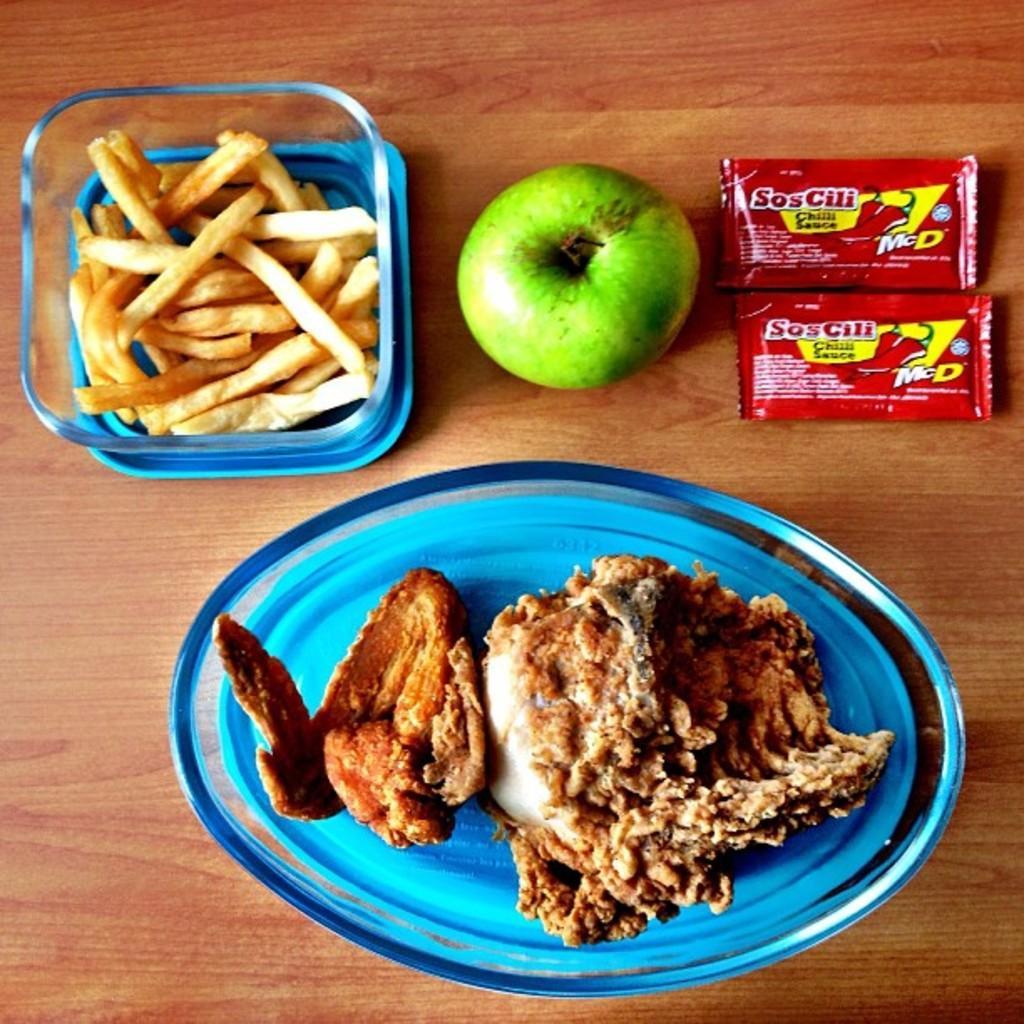Please provide a concise description of this image. In this image we can see a green apple, sauce packets, a bowl of french fries and also a plate of food. In the background we can see the wooden surface. 